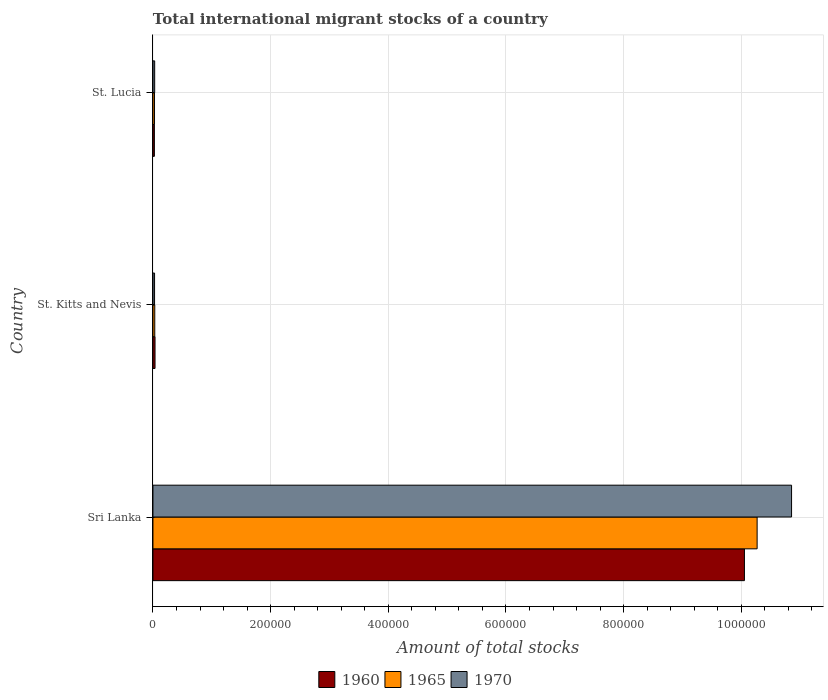How many different coloured bars are there?
Your response must be concise. 3. Are the number of bars per tick equal to the number of legend labels?
Make the answer very short. Yes. Are the number of bars on each tick of the Y-axis equal?
Your answer should be compact. Yes. How many bars are there on the 1st tick from the bottom?
Keep it short and to the point. 3. What is the label of the 3rd group of bars from the top?
Keep it short and to the point. Sri Lanka. What is the amount of total stocks in in 1970 in Sri Lanka?
Ensure brevity in your answer.  1.09e+06. Across all countries, what is the maximum amount of total stocks in in 1970?
Offer a very short reply. 1.09e+06. Across all countries, what is the minimum amount of total stocks in in 1960?
Offer a very short reply. 2448. In which country was the amount of total stocks in in 1960 maximum?
Your answer should be compact. Sri Lanka. In which country was the amount of total stocks in in 1970 minimum?
Give a very brief answer. St. Kitts and Nevis. What is the total amount of total stocks in in 1960 in the graph?
Offer a terse response. 1.01e+06. What is the difference between the amount of total stocks in in 1965 in Sri Lanka and that in St. Lucia?
Offer a terse response. 1.02e+06. What is the difference between the amount of total stocks in in 1960 in Sri Lanka and the amount of total stocks in in 1965 in St. Kitts and Nevis?
Keep it short and to the point. 1.00e+06. What is the average amount of total stocks in in 1965 per country?
Offer a very short reply. 3.44e+05. What is the difference between the amount of total stocks in in 1965 and amount of total stocks in in 1960 in St. Lucia?
Give a very brief answer. 233. What is the ratio of the amount of total stocks in in 1970 in Sri Lanka to that in St. Lucia?
Your answer should be compact. 369.57. Is the amount of total stocks in in 1960 in Sri Lanka less than that in St. Lucia?
Give a very brief answer. No. Is the difference between the amount of total stocks in in 1965 in Sri Lanka and St. Lucia greater than the difference between the amount of total stocks in in 1960 in Sri Lanka and St. Lucia?
Your answer should be compact. Yes. What is the difference between the highest and the second highest amount of total stocks in in 1965?
Keep it short and to the point. 1.02e+06. What is the difference between the highest and the lowest amount of total stocks in in 1970?
Make the answer very short. 1.08e+06. What does the 3rd bar from the top in Sri Lanka represents?
Offer a very short reply. 1960. What does the 2nd bar from the bottom in St. Lucia represents?
Your answer should be very brief. 1965. How many bars are there?
Provide a succinct answer. 9. How many countries are there in the graph?
Your answer should be very brief. 3. Are the values on the major ticks of X-axis written in scientific E-notation?
Offer a terse response. No. Does the graph contain any zero values?
Ensure brevity in your answer.  No. Where does the legend appear in the graph?
Your answer should be compact. Bottom center. What is the title of the graph?
Make the answer very short. Total international migrant stocks of a country. Does "1987" appear as one of the legend labels in the graph?
Provide a short and direct response. No. What is the label or title of the X-axis?
Give a very brief answer. Amount of total stocks. What is the label or title of the Y-axis?
Give a very brief answer. Country. What is the Amount of total stocks of 1960 in Sri Lanka?
Provide a short and direct response. 1.01e+06. What is the Amount of total stocks of 1965 in Sri Lanka?
Keep it short and to the point. 1.03e+06. What is the Amount of total stocks of 1970 in Sri Lanka?
Offer a terse response. 1.09e+06. What is the Amount of total stocks of 1960 in St. Kitts and Nevis?
Your answer should be compact. 3537. What is the Amount of total stocks of 1965 in St. Kitts and Nevis?
Ensure brevity in your answer.  3103. What is the Amount of total stocks of 1970 in St. Kitts and Nevis?
Provide a succinct answer. 2735. What is the Amount of total stocks in 1960 in St. Lucia?
Keep it short and to the point. 2448. What is the Amount of total stocks in 1965 in St. Lucia?
Offer a terse response. 2681. What is the Amount of total stocks in 1970 in St. Lucia?
Offer a very short reply. 2937. Across all countries, what is the maximum Amount of total stocks of 1960?
Ensure brevity in your answer.  1.01e+06. Across all countries, what is the maximum Amount of total stocks in 1965?
Your answer should be very brief. 1.03e+06. Across all countries, what is the maximum Amount of total stocks of 1970?
Keep it short and to the point. 1.09e+06. Across all countries, what is the minimum Amount of total stocks of 1960?
Offer a terse response. 2448. Across all countries, what is the minimum Amount of total stocks in 1965?
Your answer should be compact. 2681. Across all countries, what is the minimum Amount of total stocks of 1970?
Ensure brevity in your answer.  2735. What is the total Amount of total stocks of 1960 in the graph?
Provide a succinct answer. 1.01e+06. What is the total Amount of total stocks in 1965 in the graph?
Keep it short and to the point. 1.03e+06. What is the total Amount of total stocks in 1970 in the graph?
Provide a short and direct response. 1.09e+06. What is the difference between the Amount of total stocks of 1960 in Sri Lanka and that in St. Kitts and Nevis?
Offer a terse response. 1.00e+06. What is the difference between the Amount of total stocks of 1965 in Sri Lanka and that in St. Kitts and Nevis?
Your response must be concise. 1.02e+06. What is the difference between the Amount of total stocks in 1970 in Sri Lanka and that in St. Kitts and Nevis?
Ensure brevity in your answer.  1.08e+06. What is the difference between the Amount of total stocks of 1960 in Sri Lanka and that in St. Lucia?
Give a very brief answer. 1.00e+06. What is the difference between the Amount of total stocks in 1965 in Sri Lanka and that in St. Lucia?
Offer a terse response. 1.02e+06. What is the difference between the Amount of total stocks of 1970 in Sri Lanka and that in St. Lucia?
Offer a terse response. 1.08e+06. What is the difference between the Amount of total stocks in 1960 in St. Kitts and Nevis and that in St. Lucia?
Your answer should be compact. 1089. What is the difference between the Amount of total stocks of 1965 in St. Kitts and Nevis and that in St. Lucia?
Provide a succinct answer. 422. What is the difference between the Amount of total stocks of 1970 in St. Kitts and Nevis and that in St. Lucia?
Give a very brief answer. -202. What is the difference between the Amount of total stocks in 1960 in Sri Lanka and the Amount of total stocks in 1965 in St. Kitts and Nevis?
Make the answer very short. 1.00e+06. What is the difference between the Amount of total stocks in 1960 in Sri Lanka and the Amount of total stocks in 1970 in St. Kitts and Nevis?
Keep it short and to the point. 1.00e+06. What is the difference between the Amount of total stocks of 1965 in Sri Lanka and the Amount of total stocks of 1970 in St. Kitts and Nevis?
Make the answer very short. 1.02e+06. What is the difference between the Amount of total stocks of 1960 in Sri Lanka and the Amount of total stocks of 1965 in St. Lucia?
Provide a succinct answer. 1.00e+06. What is the difference between the Amount of total stocks of 1960 in Sri Lanka and the Amount of total stocks of 1970 in St. Lucia?
Ensure brevity in your answer.  1.00e+06. What is the difference between the Amount of total stocks of 1965 in Sri Lanka and the Amount of total stocks of 1970 in St. Lucia?
Provide a short and direct response. 1.02e+06. What is the difference between the Amount of total stocks of 1960 in St. Kitts and Nevis and the Amount of total stocks of 1965 in St. Lucia?
Your response must be concise. 856. What is the difference between the Amount of total stocks of 1960 in St. Kitts and Nevis and the Amount of total stocks of 1970 in St. Lucia?
Your answer should be very brief. 600. What is the difference between the Amount of total stocks in 1965 in St. Kitts and Nevis and the Amount of total stocks in 1970 in St. Lucia?
Your answer should be compact. 166. What is the average Amount of total stocks of 1960 per country?
Ensure brevity in your answer.  3.37e+05. What is the average Amount of total stocks of 1965 per country?
Provide a short and direct response. 3.44e+05. What is the average Amount of total stocks of 1970 per country?
Your answer should be very brief. 3.64e+05. What is the difference between the Amount of total stocks of 1960 and Amount of total stocks of 1965 in Sri Lanka?
Keep it short and to the point. -2.16e+04. What is the difference between the Amount of total stocks in 1960 and Amount of total stocks in 1970 in Sri Lanka?
Your answer should be compact. -8.01e+04. What is the difference between the Amount of total stocks in 1965 and Amount of total stocks in 1970 in Sri Lanka?
Provide a short and direct response. -5.85e+04. What is the difference between the Amount of total stocks of 1960 and Amount of total stocks of 1965 in St. Kitts and Nevis?
Your answer should be very brief. 434. What is the difference between the Amount of total stocks in 1960 and Amount of total stocks in 1970 in St. Kitts and Nevis?
Ensure brevity in your answer.  802. What is the difference between the Amount of total stocks in 1965 and Amount of total stocks in 1970 in St. Kitts and Nevis?
Provide a succinct answer. 368. What is the difference between the Amount of total stocks in 1960 and Amount of total stocks in 1965 in St. Lucia?
Offer a very short reply. -233. What is the difference between the Amount of total stocks of 1960 and Amount of total stocks of 1970 in St. Lucia?
Ensure brevity in your answer.  -489. What is the difference between the Amount of total stocks in 1965 and Amount of total stocks in 1970 in St. Lucia?
Offer a very short reply. -256. What is the ratio of the Amount of total stocks of 1960 in Sri Lanka to that in St. Kitts and Nevis?
Offer a terse response. 284.23. What is the ratio of the Amount of total stocks of 1965 in Sri Lanka to that in St. Kitts and Nevis?
Your response must be concise. 330.93. What is the ratio of the Amount of total stocks in 1970 in Sri Lanka to that in St. Kitts and Nevis?
Give a very brief answer. 396.86. What is the ratio of the Amount of total stocks in 1960 in Sri Lanka to that in St. Lucia?
Give a very brief answer. 410.67. What is the ratio of the Amount of total stocks in 1965 in Sri Lanka to that in St. Lucia?
Make the answer very short. 383.03. What is the ratio of the Amount of total stocks in 1970 in Sri Lanka to that in St. Lucia?
Offer a very short reply. 369.57. What is the ratio of the Amount of total stocks in 1960 in St. Kitts and Nevis to that in St. Lucia?
Offer a very short reply. 1.44. What is the ratio of the Amount of total stocks in 1965 in St. Kitts and Nevis to that in St. Lucia?
Offer a terse response. 1.16. What is the ratio of the Amount of total stocks in 1970 in St. Kitts and Nevis to that in St. Lucia?
Your answer should be very brief. 0.93. What is the difference between the highest and the second highest Amount of total stocks in 1960?
Your answer should be compact. 1.00e+06. What is the difference between the highest and the second highest Amount of total stocks of 1965?
Make the answer very short. 1.02e+06. What is the difference between the highest and the second highest Amount of total stocks of 1970?
Ensure brevity in your answer.  1.08e+06. What is the difference between the highest and the lowest Amount of total stocks of 1960?
Keep it short and to the point. 1.00e+06. What is the difference between the highest and the lowest Amount of total stocks of 1965?
Give a very brief answer. 1.02e+06. What is the difference between the highest and the lowest Amount of total stocks in 1970?
Offer a very short reply. 1.08e+06. 